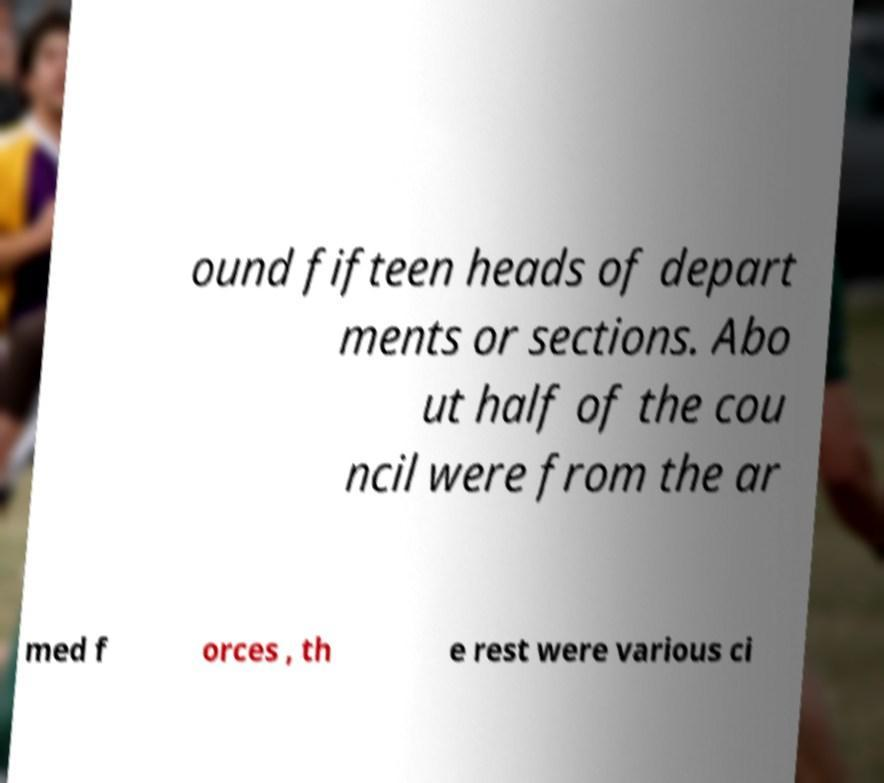Can you read and provide the text displayed in the image?This photo seems to have some interesting text. Can you extract and type it out for me? ound fifteen heads of depart ments or sections. Abo ut half of the cou ncil were from the ar med f orces , th e rest were various ci 